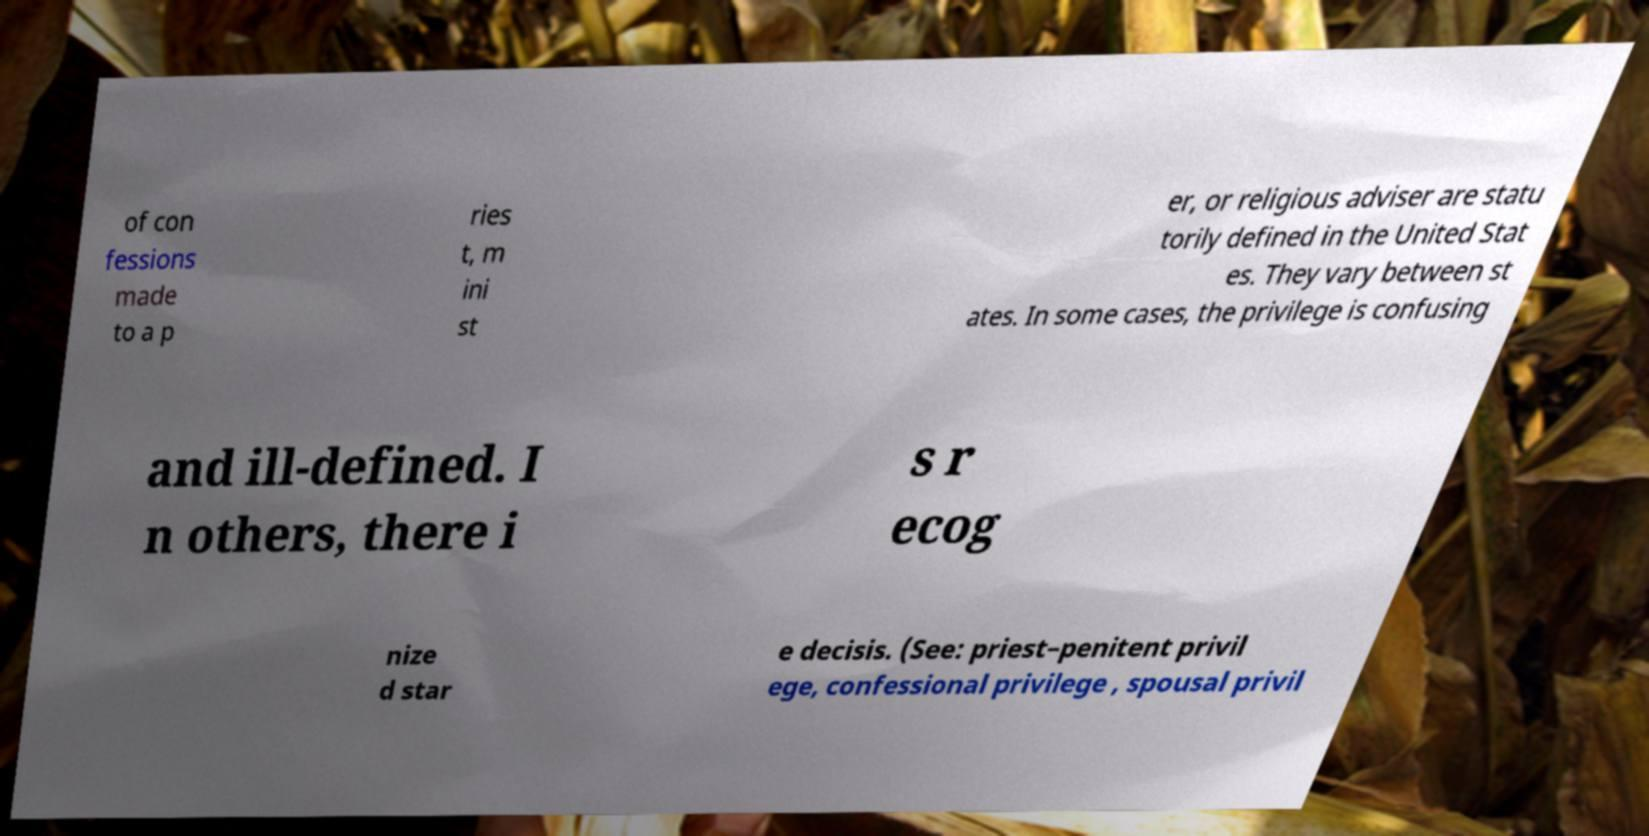Could you assist in decoding the text presented in this image and type it out clearly? of con fessions made to a p ries t, m ini st er, or religious adviser are statu torily defined in the United Stat es. They vary between st ates. In some cases, the privilege is confusing and ill-defined. I n others, there i s r ecog nize d star e decisis. (See: priest–penitent privil ege, confessional privilege , spousal privil 